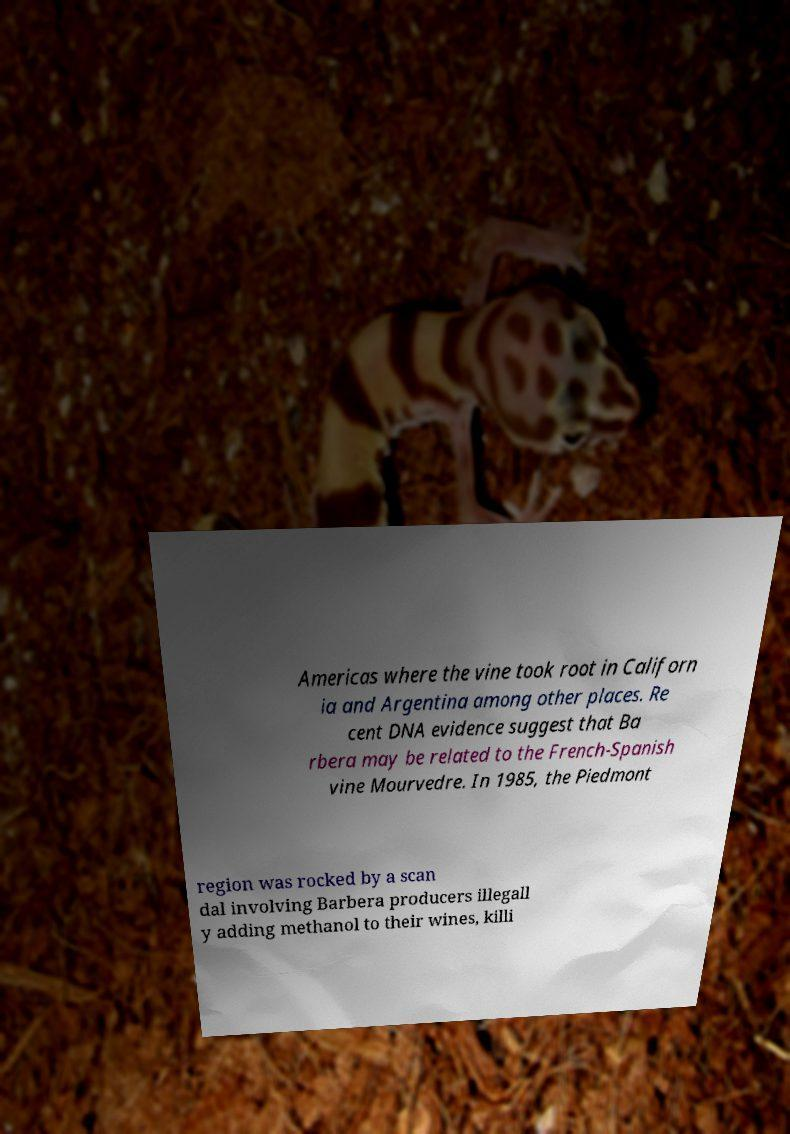What messages or text are displayed in this image? I need them in a readable, typed format. Americas where the vine took root in Californ ia and Argentina among other places. Re cent DNA evidence suggest that Ba rbera may be related to the French-Spanish vine Mourvedre. In 1985, the Piedmont region was rocked by a scan dal involving Barbera producers illegall y adding methanol to their wines, killi 